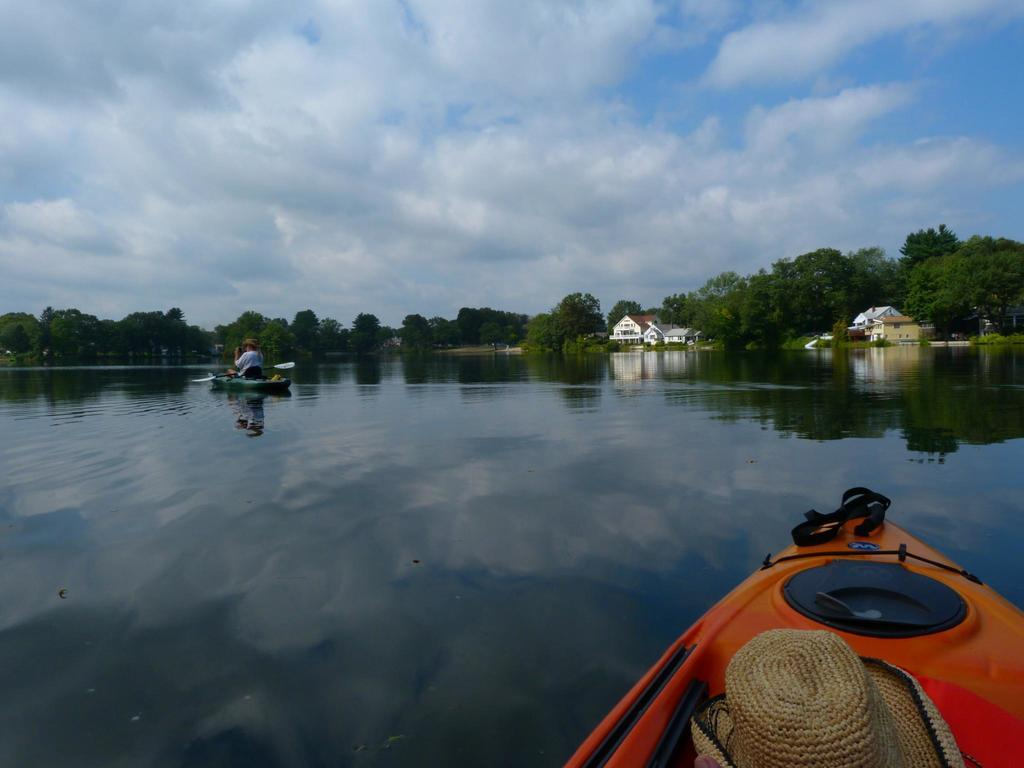What can be seen floating on the water in the image? There are two boats in the water. What accessory is present in the image? There is a hat in the image. What is the man in the image holding? The man is holding a paddle in his hands. What structures can be seen in the background of the image? There are buildings in the background of the image. What type of vegetation is visible in the background of the image? There are trees in the background of the image. What is visible in the sky in the image? The sky is visible in the background of the image, and clouds are present. What type of chair is the man sitting on in the image? There is no chair present in the image; the man is standing and holding a paddle. What does the man need to learn in order to paddle the boat? The image does not provide information about the man's paddling skills or what he needs to learn. 